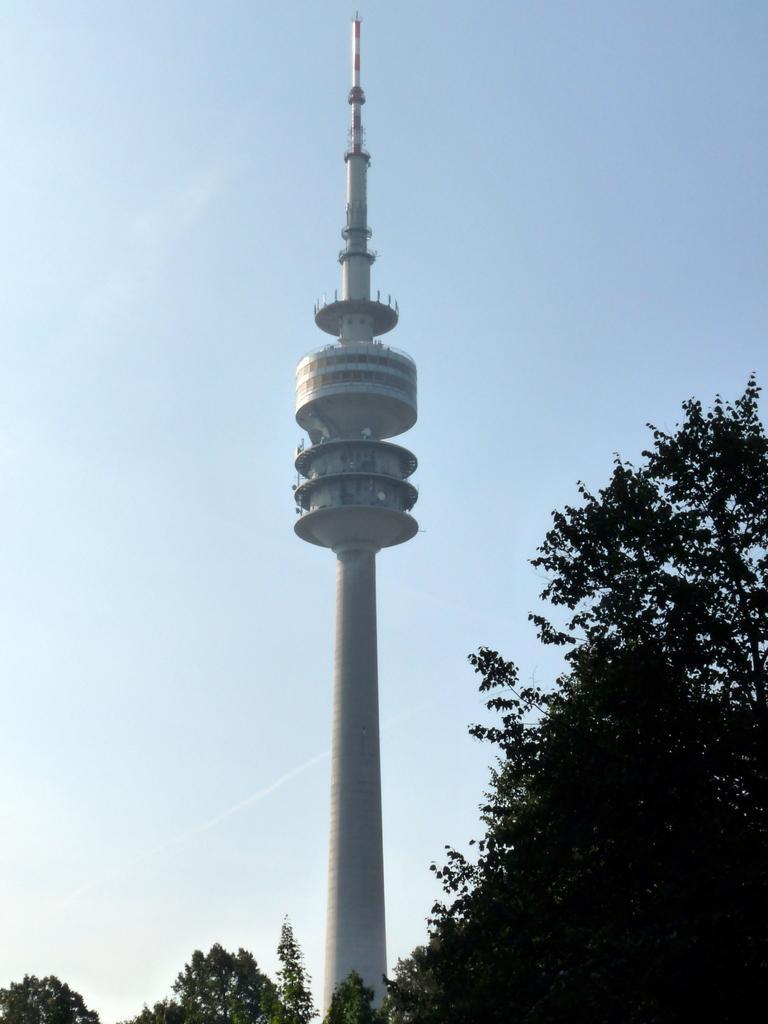Describe this image in one or two sentences. In this image in the front there are trees. In the center there is a tower. 